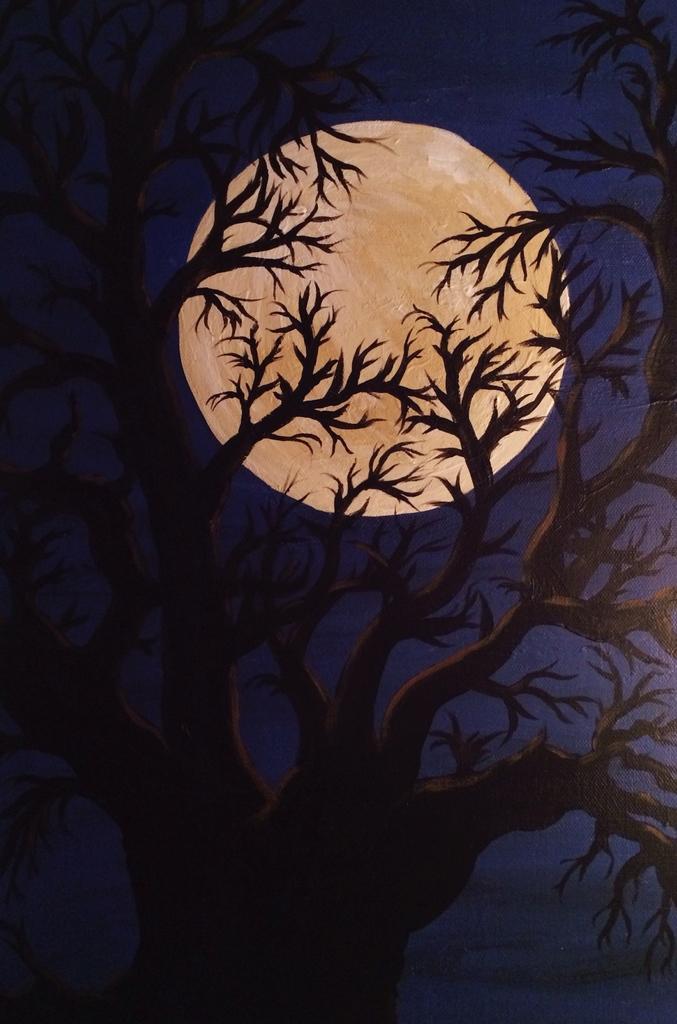In one or two sentences, can you explain what this image depicts? This image consists of a paper with a painting of a tree and a moon in the sky on it. 